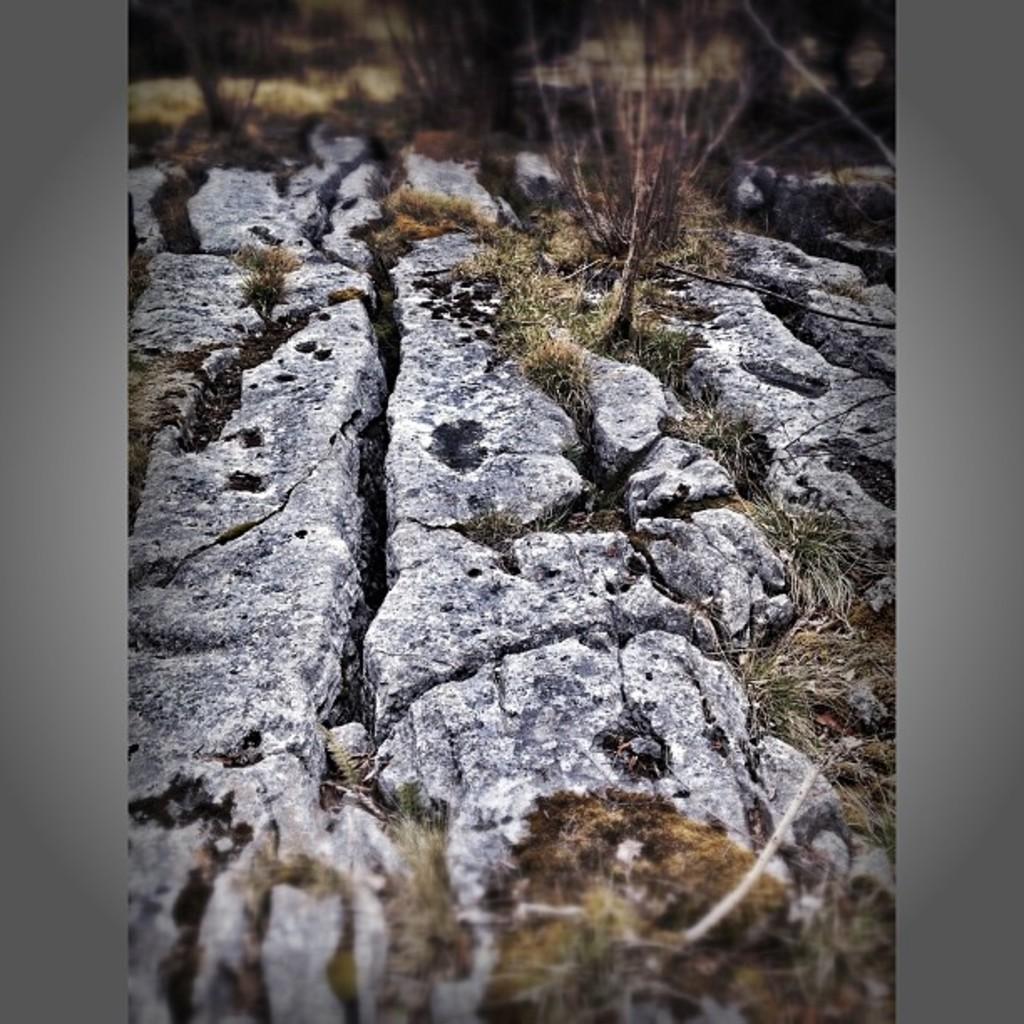How would you summarize this image in a sentence or two? In this image at the bottom there is a walkway and some grass, in the background there are some plants and grass. 